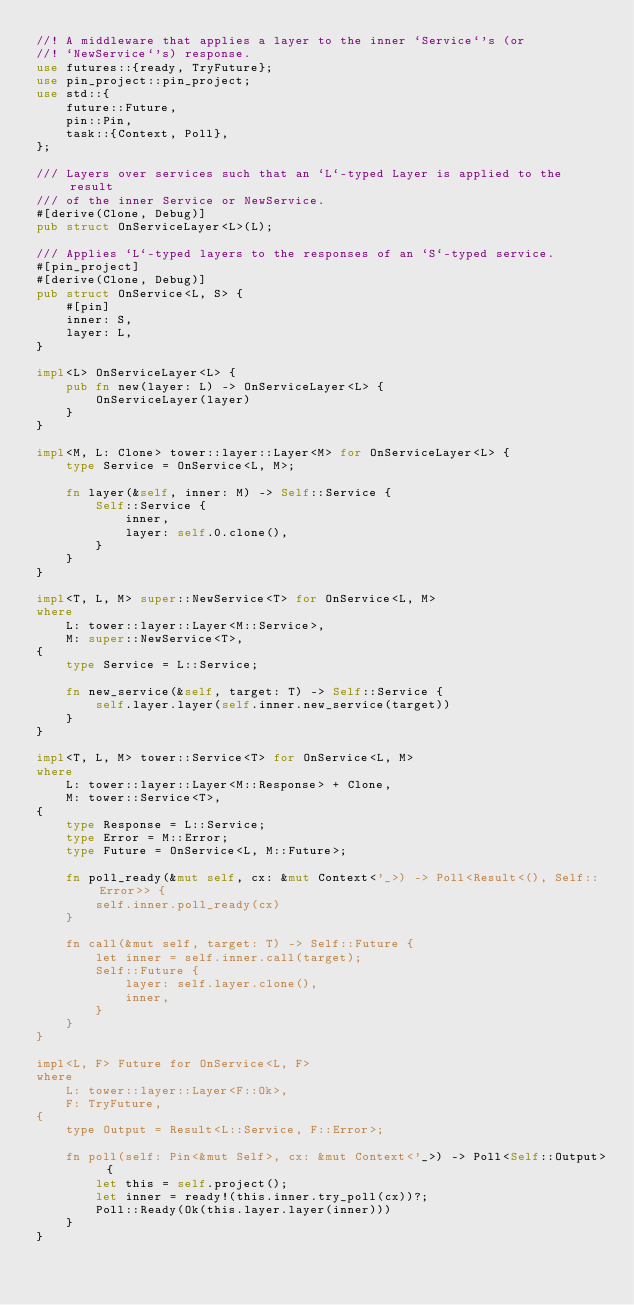<code> <loc_0><loc_0><loc_500><loc_500><_Rust_>//! A middleware that applies a layer to the inner `Service`'s (or
//! `NewService`'s) response.
use futures::{ready, TryFuture};
use pin_project::pin_project;
use std::{
    future::Future,
    pin::Pin,
    task::{Context, Poll},
};

/// Layers over services such that an `L`-typed Layer is applied to the result
/// of the inner Service or NewService.
#[derive(Clone, Debug)]
pub struct OnServiceLayer<L>(L);

/// Applies `L`-typed layers to the responses of an `S`-typed service.
#[pin_project]
#[derive(Clone, Debug)]
pub struct OnService<L, S> {
    #[pin]
    inner: S,
    layer: L,
}

impl<L> OnServiceLayer<L> {
    pub fn new(layer: L) -> OnServiceLayer<L> {
        OnServiceLayer(layer)
    }
}

impl<M, L: Clone> tower::layer::Layer<M> for OnServiceLayer<L> {
    type Service = OnService<L, M>;

    fn layer(&self, inner: M) -> Self::Service {
        Self::Service {
            inner,
            layer: self.0.clone(),
        }
    }
}

impl<T, L, M> super::NewService<T> for OnService<L, M>
where
    L: tower::layer::Layer<M::Service>,
    M: super::NewService<T>,
{
    type Service = L::Service;

    fn new_service(&self, target: T) -> Self::Service {
        self.layer.layer(self.inner.new_service(target))
    }
}

impl<T, L, M> tower::Service<T> for OnService<L, M>
where
    L: tower::layer::Layer<M::Response> + Clone,
    M: tower::Service<T>,
{
    type Response = L::Service;
    type Error = M::Error;
    type Future = OnService<L, M::Future>;

    fn poll_ready(&mut self, cx: &mut Context<'_>) -> Poll<Result<(), Self::Error>> {
        self.inner.poll_ready(cx)
    }

    fn call(&mut self, target: T) -> Self::Future {
        let inner = self.inner.call(target);
        Self::Future {
            layer: self.layer.clone(),
            inner,
        }
    }
}

impl<L, F> Future for OnService<L, F>
where
    L: tower::layer::Layer<F::Ok>,
    F: TryFuture,
{
    type Output = Result<L::Service, F::Error>;

    fn poll(self: Pin<&mut Self>, cx: &mut Context<'_>) -> Poll<Self::Output> {
        let this = self.project();
        let inner = ready!(this.inner.try_poll(cx))?;
        Poll::Ready(Ok(this.layer.layer(inner)))
    }
}
</code> 